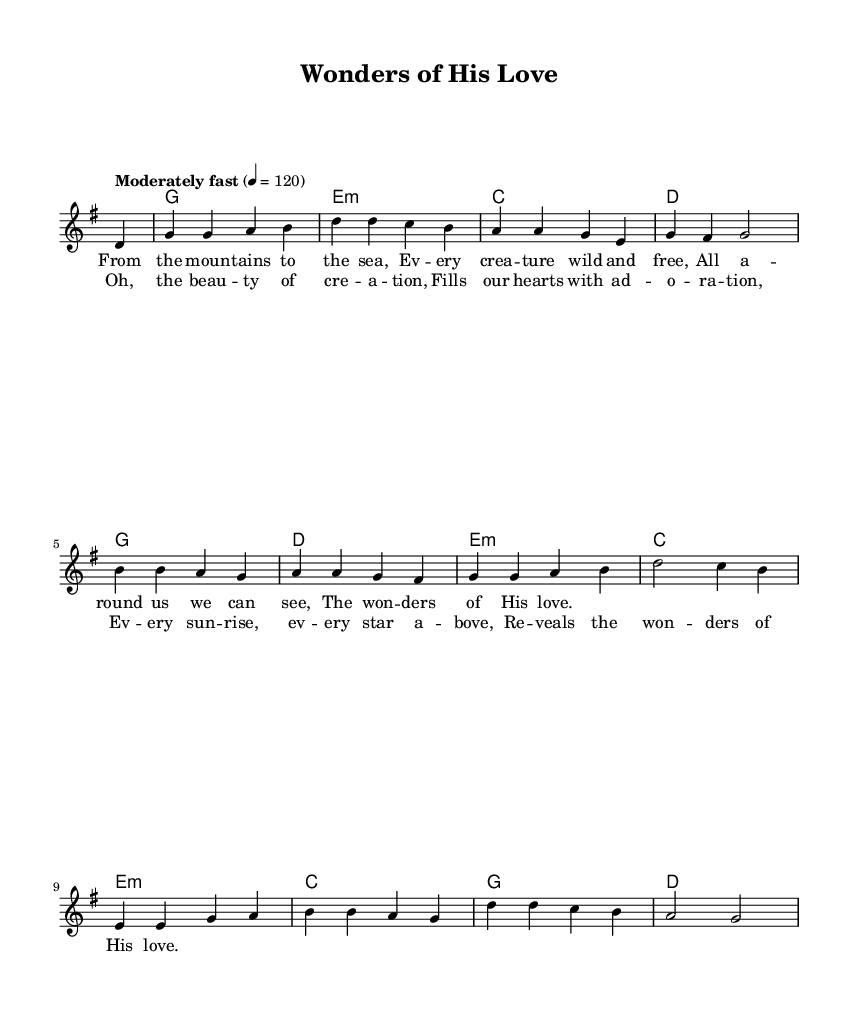What is the key signature of this music? The key signature is G major, which has one sharp (F#). This can be determined by looking at the key signature indicated at the beginning of the score, just after the Clef sign.
Answer: G major What is the time signature of the piece? The time signature is 4/4, which means there are four beats in each measure and the quarter note gets one beat. This is displayed at the beginning of the score as part of the time signature notation.
Answer: 4/4 What is the tempo marking for the piece? The tempo marking is "Moderately fast," indicated above the staff with a BPM (beats per minute) marking of 120. The tempo gives musicians guidance on how quickly to perform the piece.
Answer: Moderately fast How many measures are there in the melody? The melody consists of 8 measures. This can be counted by looking at the notation and observing the vertical lines separating each measure.
Answer: 8 What is the first lyric phrase of the verse? The first lyric phrase of the verse is "From the mountains to the sea." The lyrics are provided beneath the melody, corresponding to the notes they should be sung with.
Answer: From the mountains to the sea Which chord follows the first two measures of melody? The chord that follows the first two measures of melody is an E minor chord. This can be determined by looking at the chord symbols positioned above the measures during the first part of the song.
Answer: E minor 